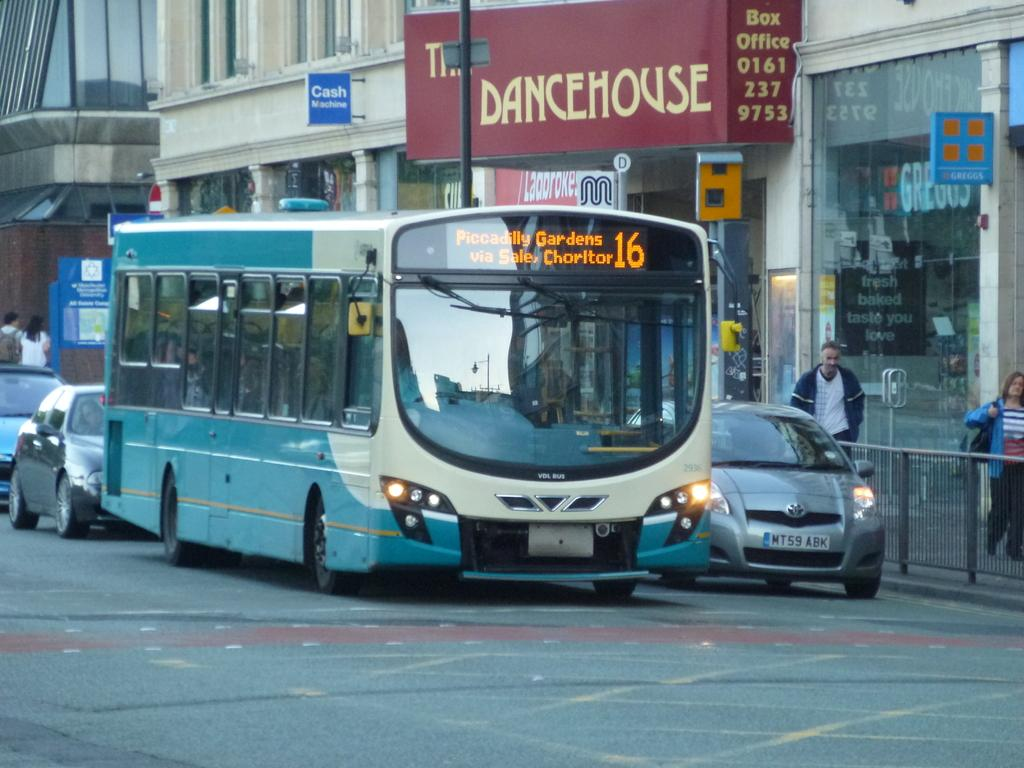What types of objects are present in the image? There are vehicles, people walking, stalls, boards, and buildings in the image. What are the people doing in the image? The people are walking in the image. What might the stalls be selling or offering? The stalls in the image could be selling or offering various items or services, but the specifics are not mentioned in the facts. What can be seen on the boards in the image? The facts do not specify what is written or displayed on the boards, so we cannot answer that question definitively. What is the reaction of the hand in the image? There is no mention of a hand in the image, so we cannot answer that question. 